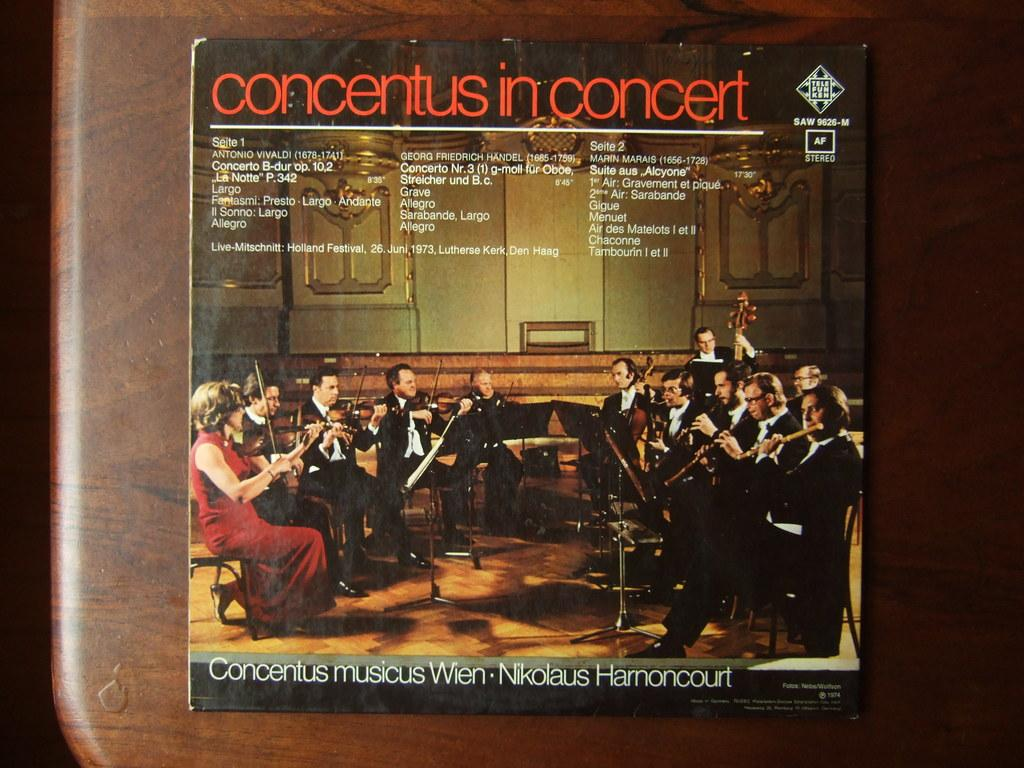<image>
Provide a brief description of the given image. A record album of Concertus in Concert showing men and women playing instruments on the cover. 